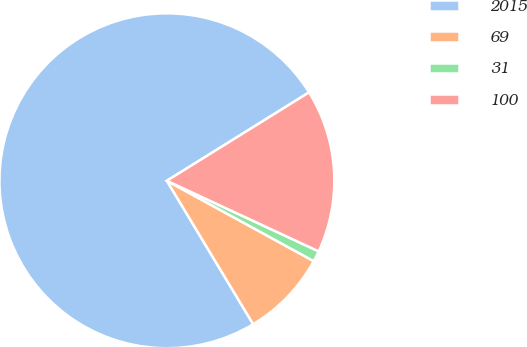<chart> <loc_0><loc_0><loc_500><loc_500><pie_chart><fcel>2015<fcel>69<fcel>31<fcel>100<nl><fcel>74.76%<fcel>8.41%<fcel>1.04%<fcel>15.78%<nl></chart> 